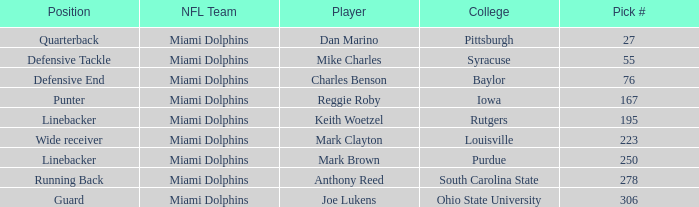If the Position is Running Back what is the Total number of Pick #? 1.0. 